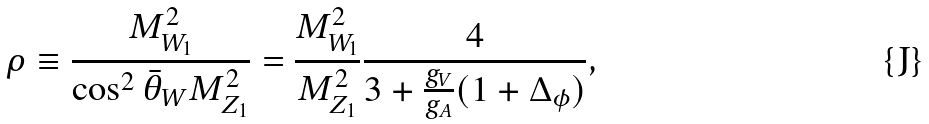<formula> <loc_0><loc_0><loc_500><loc_500>\rho \equiv \frac { M _ { W _ { 1 } } ^ { 2 } } { \cos ^ { 2 } \bar { \theta } _ { W } M _ { Z _ { 1 } } ^ { 2 } } = \frac { M _ { W _ { 1 } } ^ { 2 } } { M _ { Z _ { 1 } } ^ { 2 } } \frac { 4 } { 3 + \frac { g _ { V } } { g _ { A } } ( 1 + \Delta _ { \phi } ) } ,</formula> 